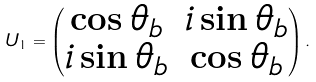<formula> <loc_0><loc_0><loc_500><loc_500>U _ { 1 } = \begin{pmatrix} \cos \theta _ { b } & i \sin \theta _ { b } \\ i \sin \theta _ { b } & \cos \theta _ { b } \\ \end{pmatrix} .</formula> 